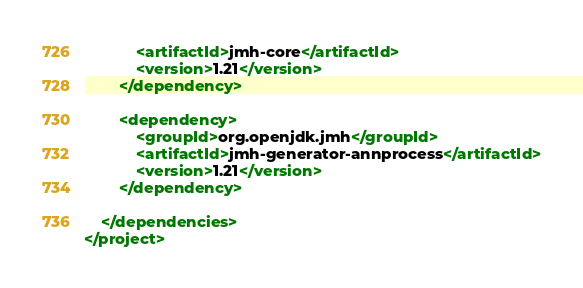<code> <loc_0><loc_0><loc_500><loc_500><_XML_>            <artifactId>jmh-core</artifactId>
            <version>1.21</version>
        </dependency>

        <dependency>
            <groupId>org.openjdk.jmh</groupId>
            <artifactId>jmh-generator-annprocess</artifactId>
            <version>1.21</version>
        </dependency>

    </dependencies>
</project>
</code> 